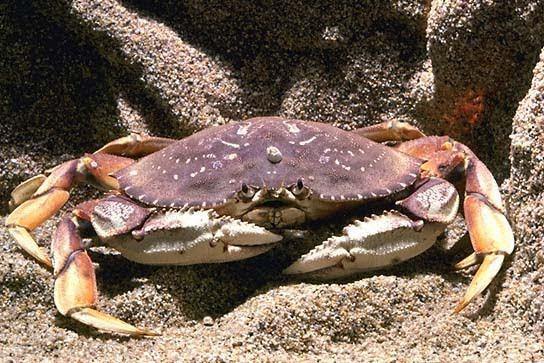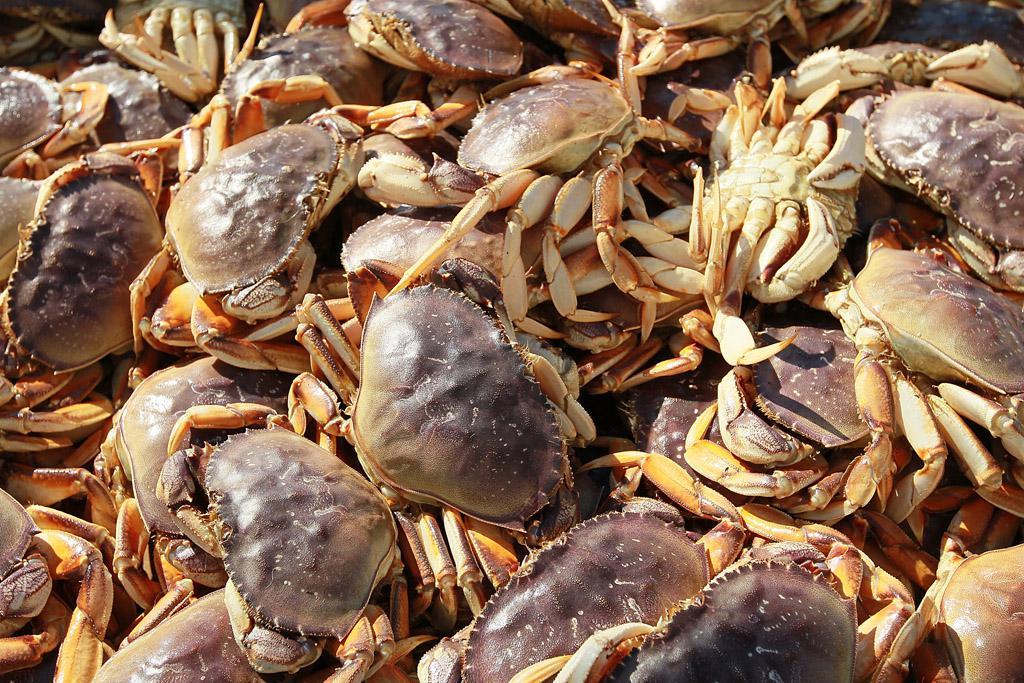The first image is the image on the left, the second image is the image on the right. Considering the images on both sides, is "The right image contains no more than one crab." valid? Answer yes or no. No. The first image is the image on the left, the second image is the image on the right. Analyze the images presented: Is the assertion "The left and right images each show only one crab, and one of the pictured crabs is on a white background and has black-tipped front claws." valid? Answer yes or no. No. 